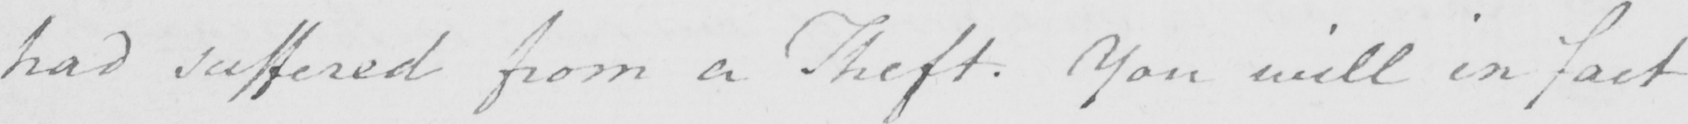Please provide the text content of this handwritten line. had suffered from a Theft . You will in fact 